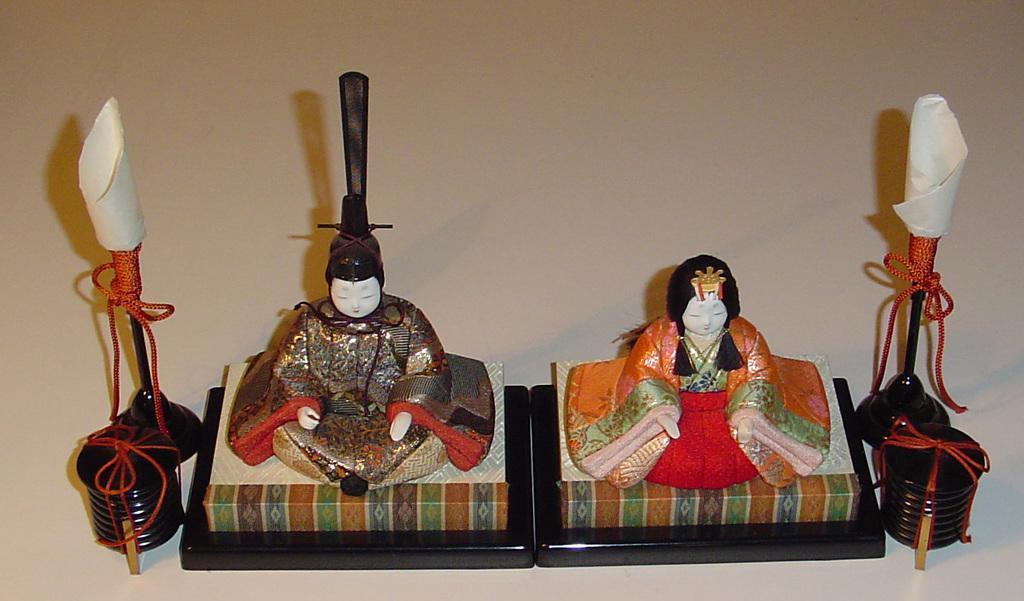Can you describe this image briefly? In this image we can see toy humans sitting on the platforms and on the left and right side there are objects and threads tied to the stands and all these are on the another platform. 